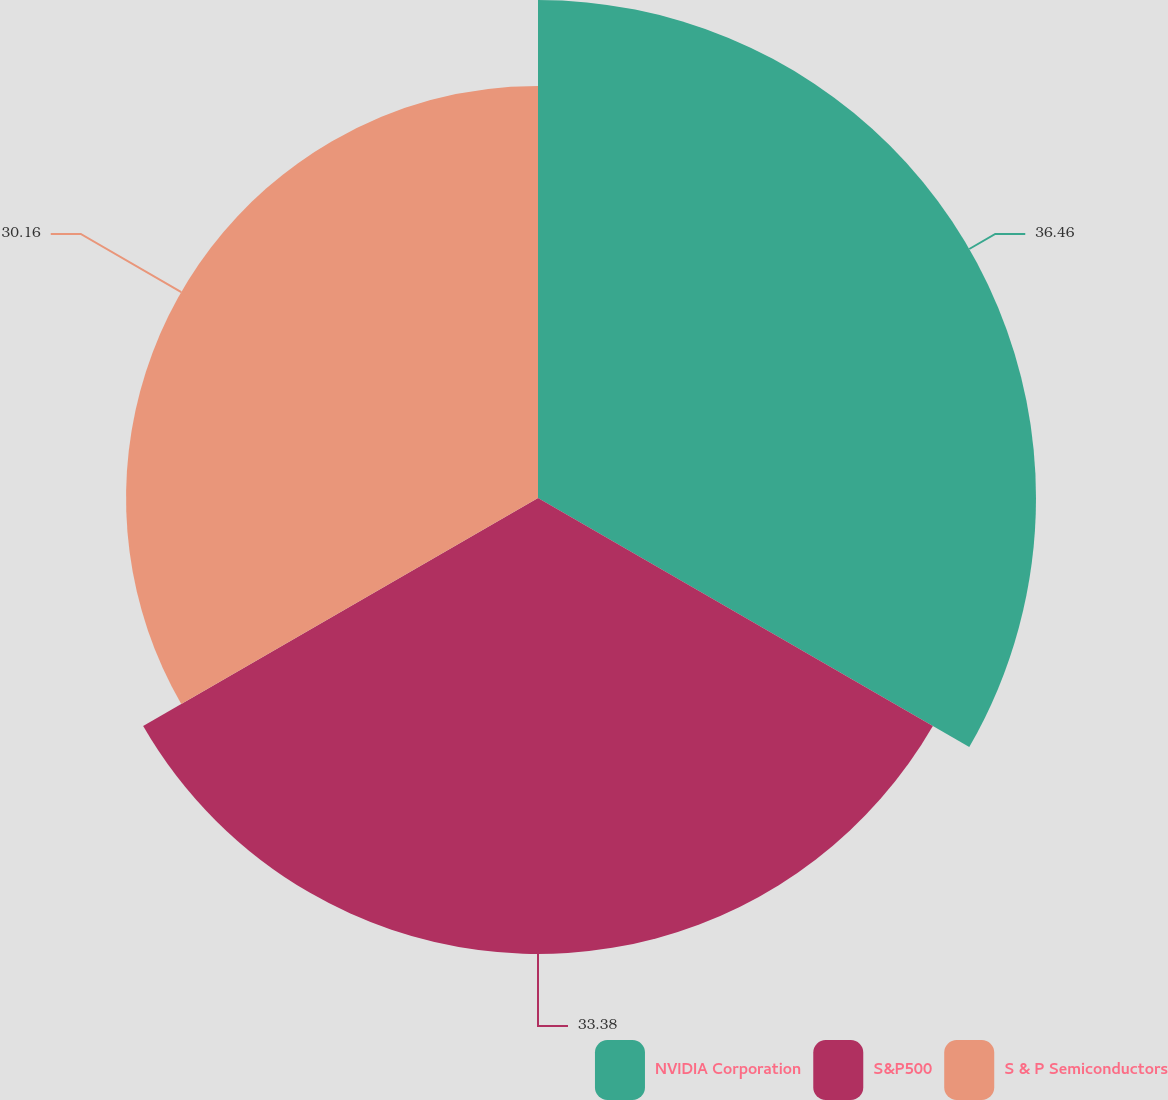Convert chart. <chart><loc_0><loc_0><loc_500><loc_500><pie_chart><fcel>NVIDIA Corporation<fcel>S&P500<fcel>S & P Semiconductors<nl><fcel>36.46%<fcel>33.38%<fcel>30.16%<nl></chart> 